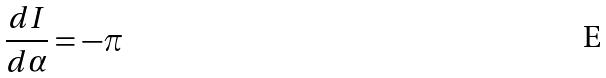<formula> <loc_0><loc_0><loc_500><loc_500>\frac { d I } { d \alpha } = - \pi</formula> 